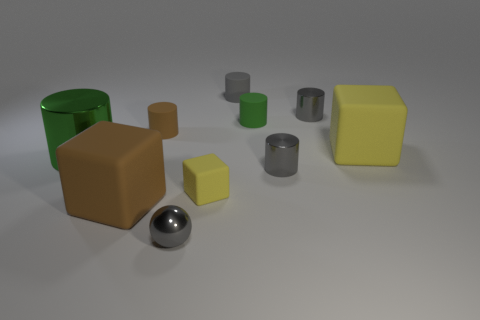Subtract all big cubes. How many cubes are left? 1 Subtract 5 cylinders. How many cylinders are left? 1 Subtract all balls. How many objects are left? 9 Subtract all brown blocks. How many blocks are left? 2 Subtract 0 yellow cylinders. How many objects are left? 10 Subtract all blue blocks. Subtract all red cylinders. How many blocks are left? 3 Subtract all green blocks. How many red balls are left? 0 Subtract all tiny matte cylinders. Subtract all gray metal cylinders. How many objects are left? 5 Add 7 large brown cubes. How many large brown cubes are left? 8 Add 5 brown rubber cubes. How many brown rubber cubes exist? 6 